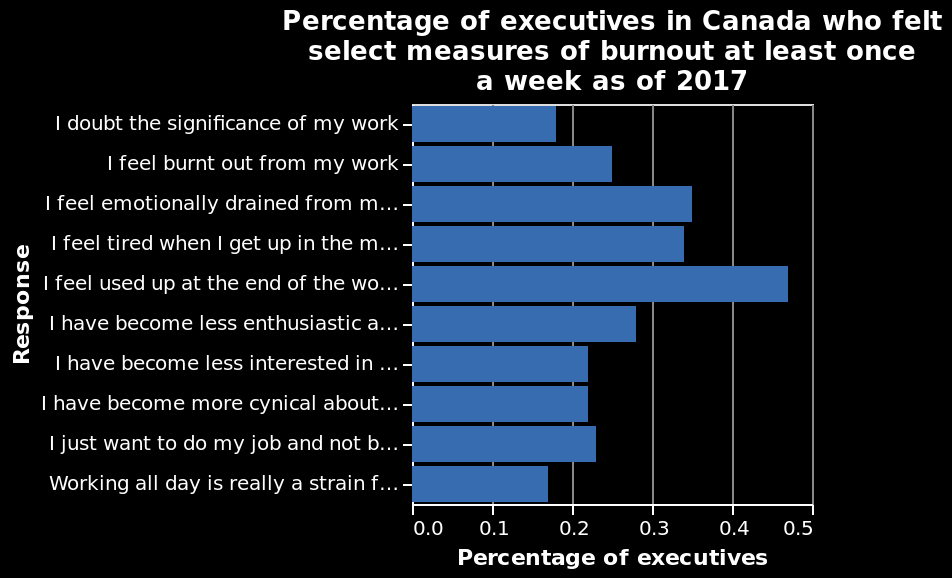<image>
What percentage of executives typically experience burn out after a working week?  Over 0.2 percentage of executives. What is the time period for which the data is provided? The data provided is for the year 2017. What is the type of chart used in the figure? The type of chart used in the figure is a bar chart. 